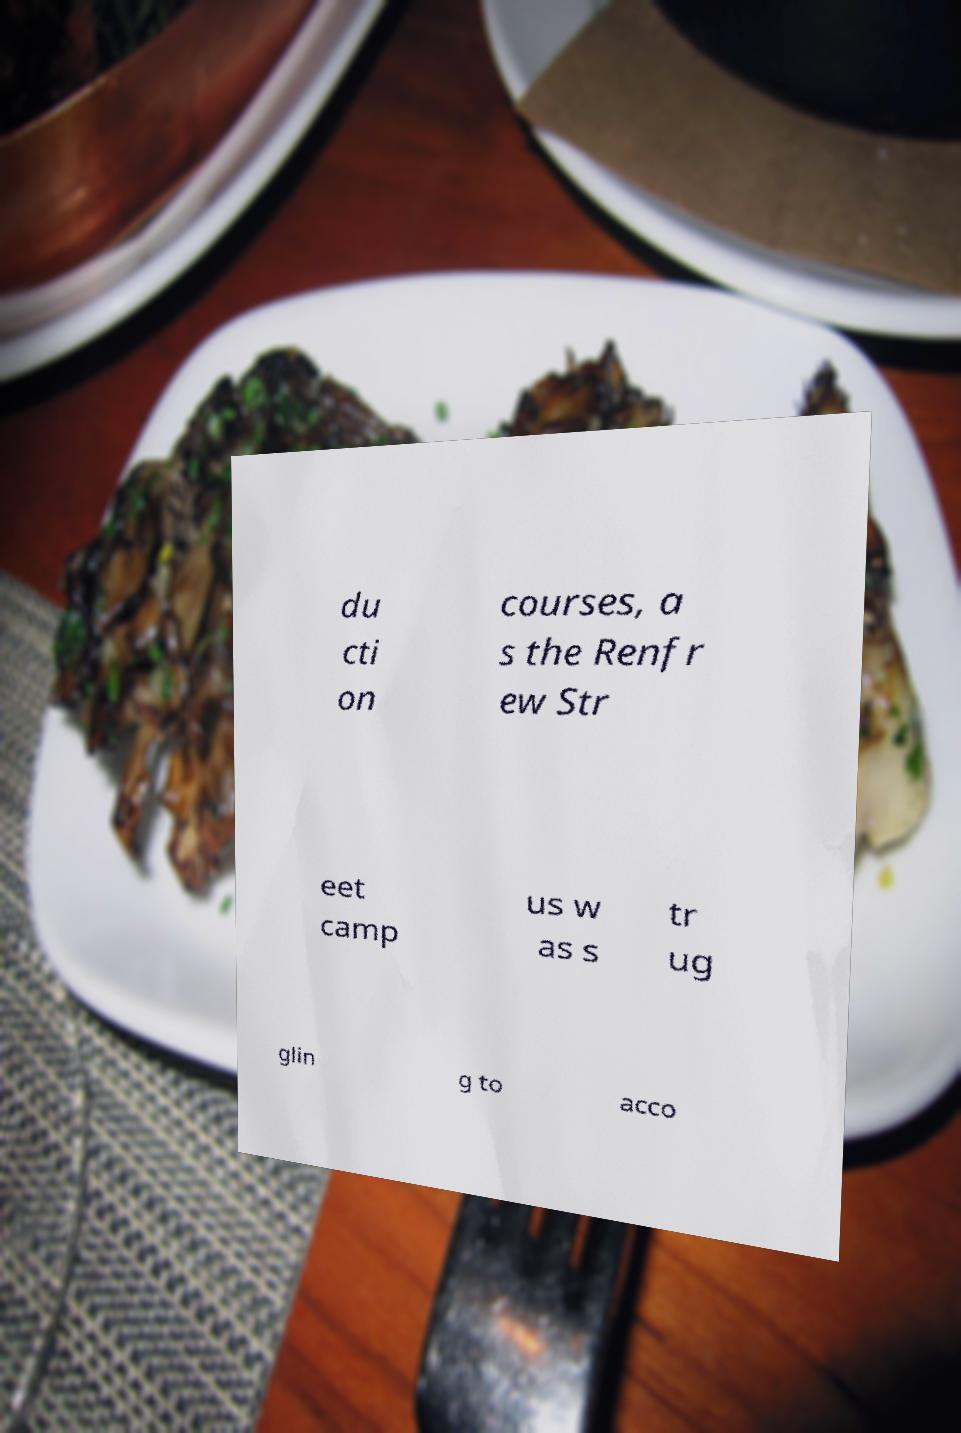For documentation purposes, I need the text within this image transcribed. Could you provide that? du cti on courses, a s the Renfr ew Str eet camp us w as s tr ug glin g to acco 